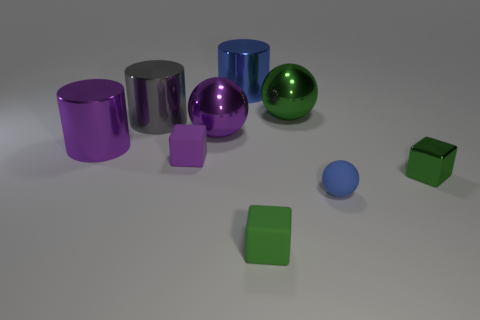Subtract all gray shiny cylinders. How many cylinders are left? 2 Subtract all purple balls. How many balls are left? 2 Subtract 1 blocks. How many blocks are left? 2 Subtract all red cubes. How many gray balls are left? 0 Subtract all yellow cylinders. Subtract all purple balls. How many cylinders are left? 3 Subtract all tiny purple metal objects. Subtract all large blue objects. How many objects are left? 8 Add 8 large gray metal things. How many large gray metal things are left? 9 Add 3 large cylinders. How many large cylinders exist? 6 Subtract 0 gray cubes. How many objects are left? 9 Subtract all cubes. How many objects are left? 6 